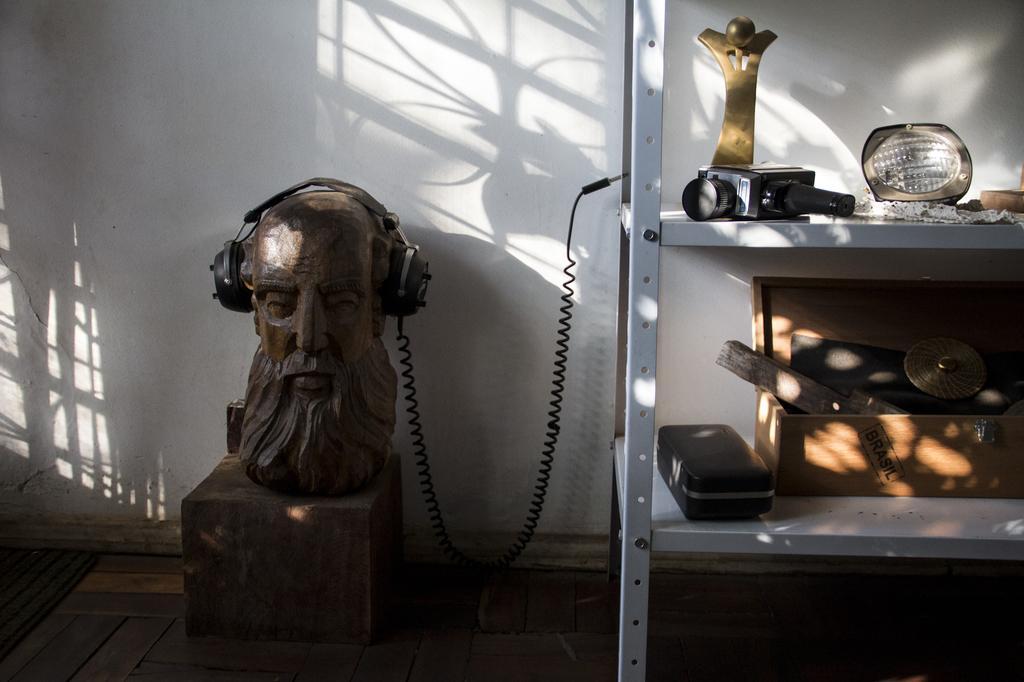Can you describe this image briefly? In this image we can see the headphones on a statue. On the right side we can see a camera, a wooden box and some objects placed on the racks. On the backside we can see a wall. 